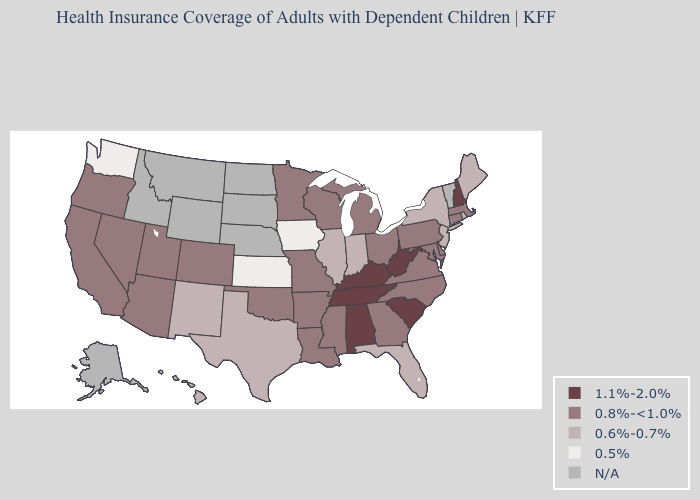Name the states that have a value in the range N/A?
Give a very brief answer. Alaska, Idaho, Montana, Nebraska, North Dakota, Rhode Island, South Dakota, Vermont, Wyoming. What is the highest value in states that border Tennessee?
Quick response, please. 1.1%-2.0%. What is the value of Nebraska?
Answer briefly. N/A. Name the states that have a value in the range 0.8%-<1.0%?
Give a very brief answer. Arizona, Arkansas, California, Colorado, Connecticut, Delaware, Georgia, Louisiana, Maryland, Massachusetts, Michigan, Minnesota, Mississippi, Missouri, Nevada, North Carolina, Ohio, Oklahoma, Oregon, Pennsylvania, Utah, Virginia, Wisconsin. Is the legend a continuous bar?
Be succinct. No. What is the value of Iowa?
Short answer required. 0.5%. Name the states that have a value in the range 1.1%-2.0%?
Be succinct. Alabama, Kentucky, New Hampshire, South Carolina, Tennessee, West Virginia. Does Kansas have the lowest value in the USA?
Concise answer only. Yes. What is the highest value in states that border Rhode Island?
Write a very short answer. 0.8%-<1.0%. Which states have the lowest value in the USA?
Concise answer only. Iowa, Kansas, Washington. Name the states that have a value in the range 0.5%?
Give a very brief answer. Iowa, Kansas, Washington. What is the value of Kansas?
Write a very short answer. 0.5%. What is the value of New York?
Write a very short answer. 0.6%-0.7%. What is the value of Michigan?
Give a very brief answer. 0.8%-<1.0%. How many symbols are there in the legend?
Answer briefly. 5. 